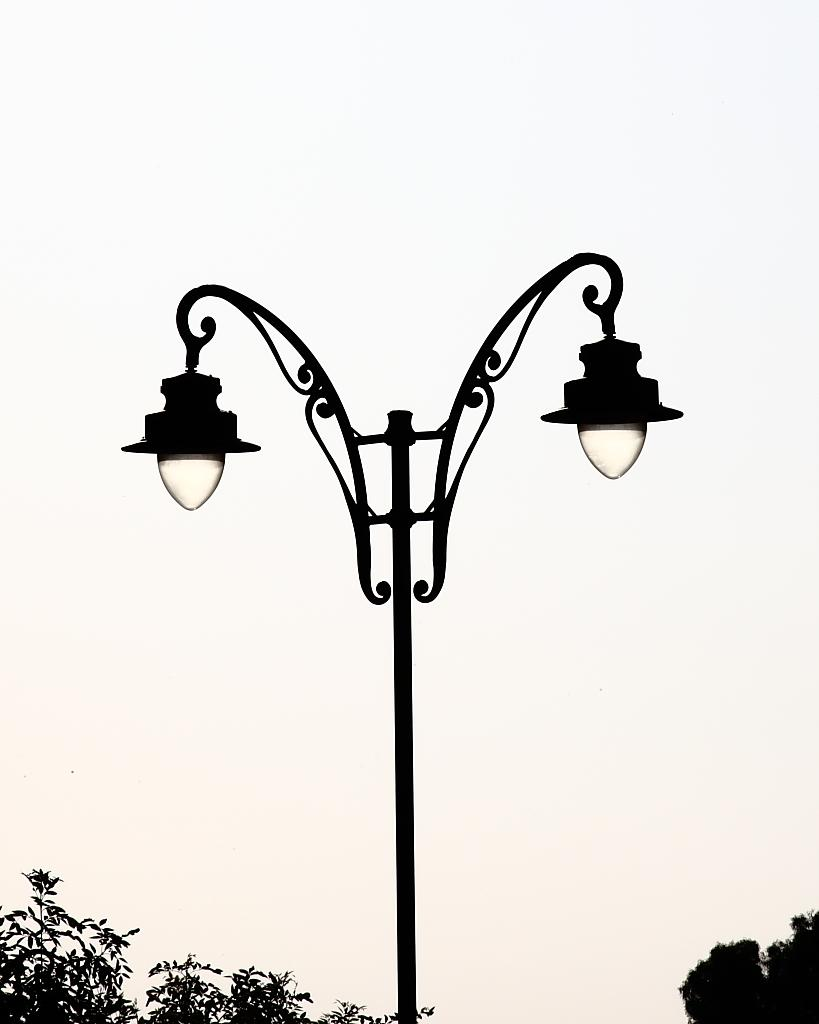What type of lighting can be seen in the image? There are street lights in the image. What type of vegetation is present at the bottom of the image? There are trees at the bottom of the image. What part of the natural environment is visible in the image? The sky is visible in the image. What type of stamp is visible on the canvas in the image? There is no stamp or canvas present in the image; it features street lights and trees. What type of test is being conducted in the image? There is no test being conducted in the image; it features street lights, trees, and the sky. 